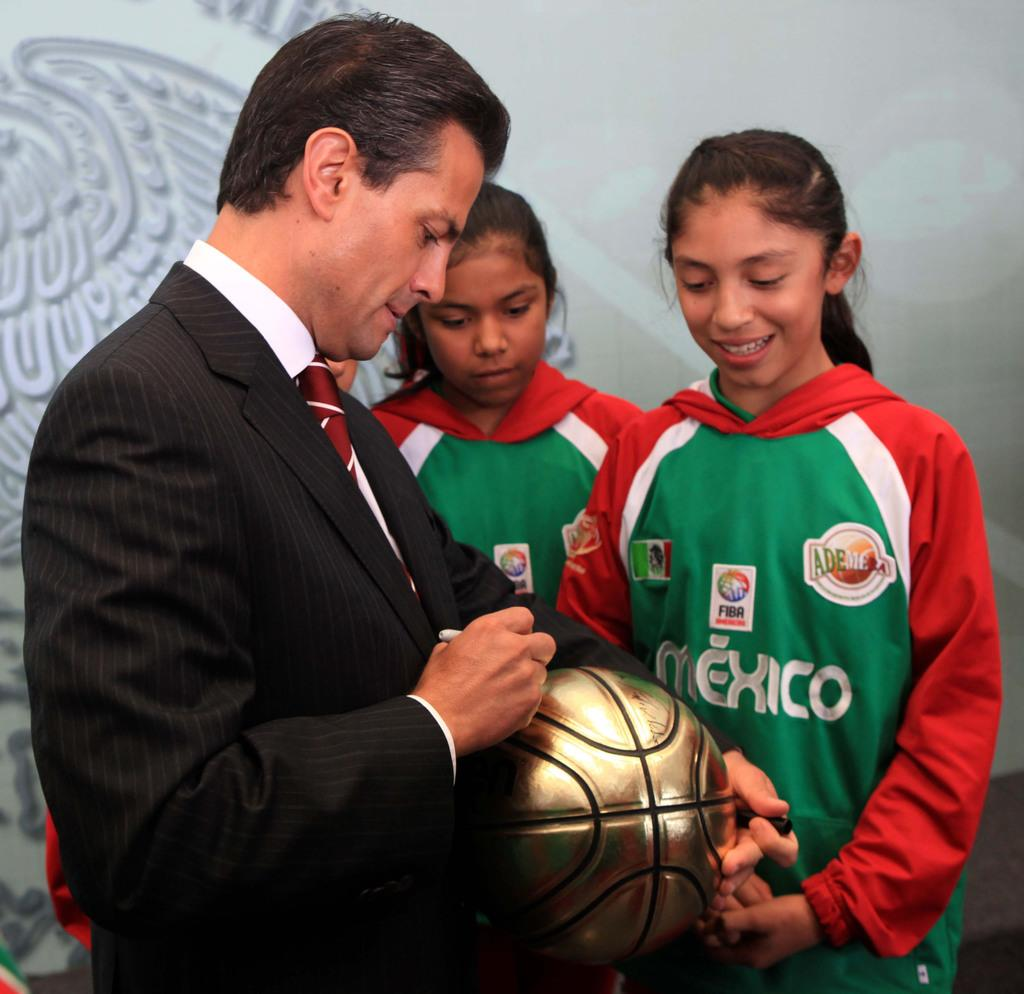<image>
Write a terse but informative summary of the picture. the man is signing a ball for the Mexican girls 